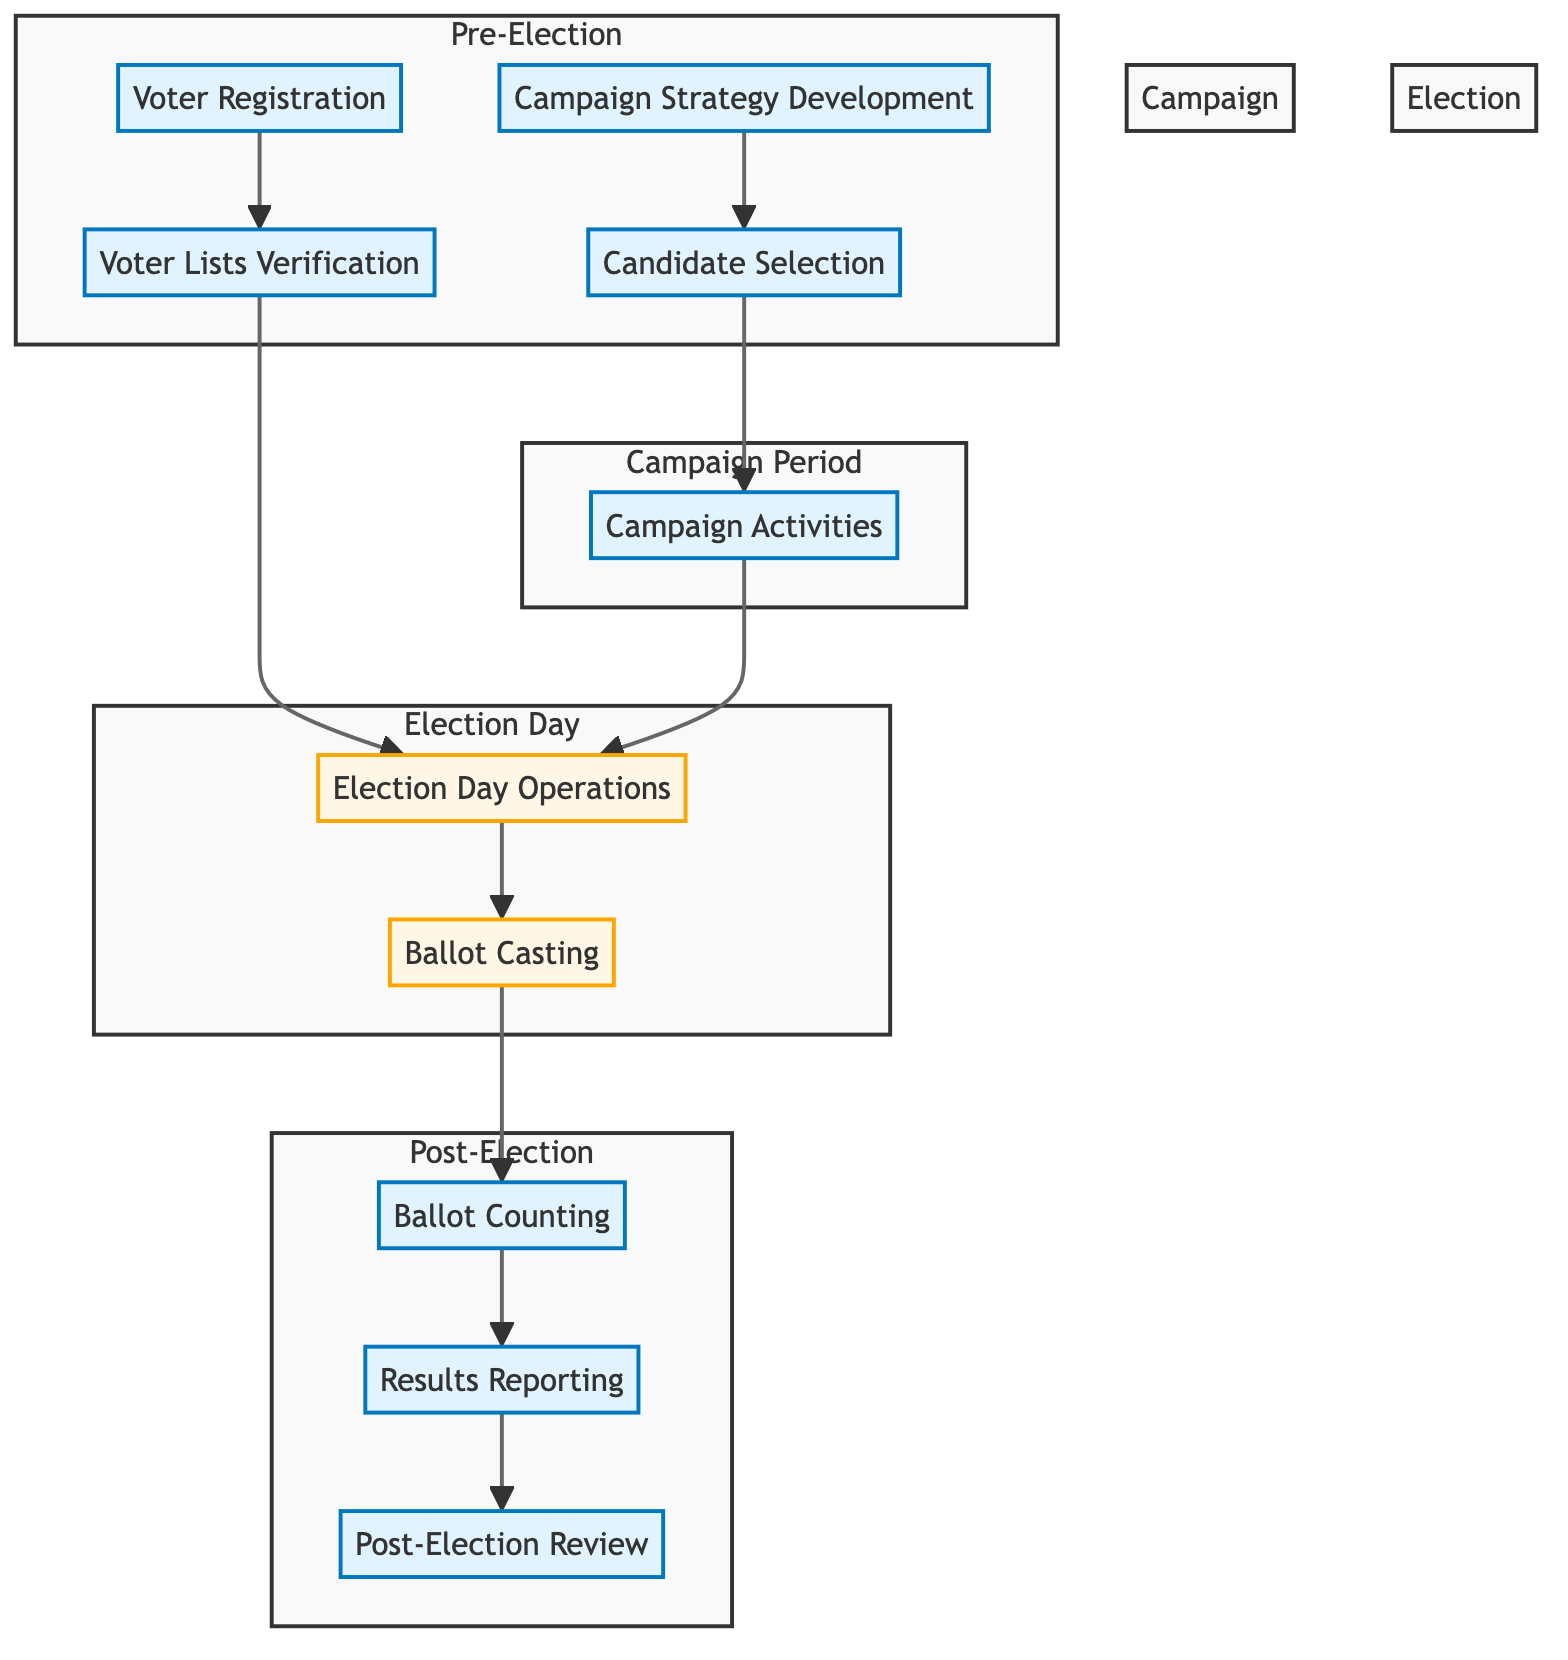What is the first step in the electoral process? The diagram indicates that the first step in the electoral process is "Voter Registration," which is where citizens begin by registering to vote.
Answer: Voter Registration How many main phases are depicted in the diagram? The diagram shows four main phases: Pre-Election, Campaign Period, Election Day, and Post-Election.
Answer: Four Which two processes must occur before Election Day? "Voter Lists Verification" and "Campaign Activities" must occur before Election Day, both of which flow into the "Election Day Operations."
Answer: Voter Lists Verification and Campaign Activities What happens to votes after Ballot Casting? After "Ballot Casting," the next process is "Ballot Counting," as indicated by the flow in the diagram.
Answer: Ballot Counting What is the final step in the electoral process? The last step is "Post-Election Review," which follows after "Results Reporting," completing the electoral process cycle.
Answer: Post-Election Review List two ways political parties engage voters during the Campaign Period. During the "Campaign Period," parties engage voters through "Campaign Activities," which involve rallies and social media.
Answer: Rallies and social media What process is directly linked to "Candidate Selection"? "Campaign Activities" is directly linked to "Candidate Selection," meaning once candidates are selected, they proceed to engage with voters through various campaign activities.
Answer: Campaign Activities What happens immediately after "Ballot Counting"? Immediately after "Ballot Counting," the next step is "Results Reporting," where the election results are officially announced.
Answer: Results Reporting What connects "Voter Lists Verification" to "Election Day Operations"? "Voter Lists Verification" connects to "Election Day Operations" as it ensures that only verified voters are allowed to participate, thereby influencing the operations on election day.
Answer: Election Day Operations 